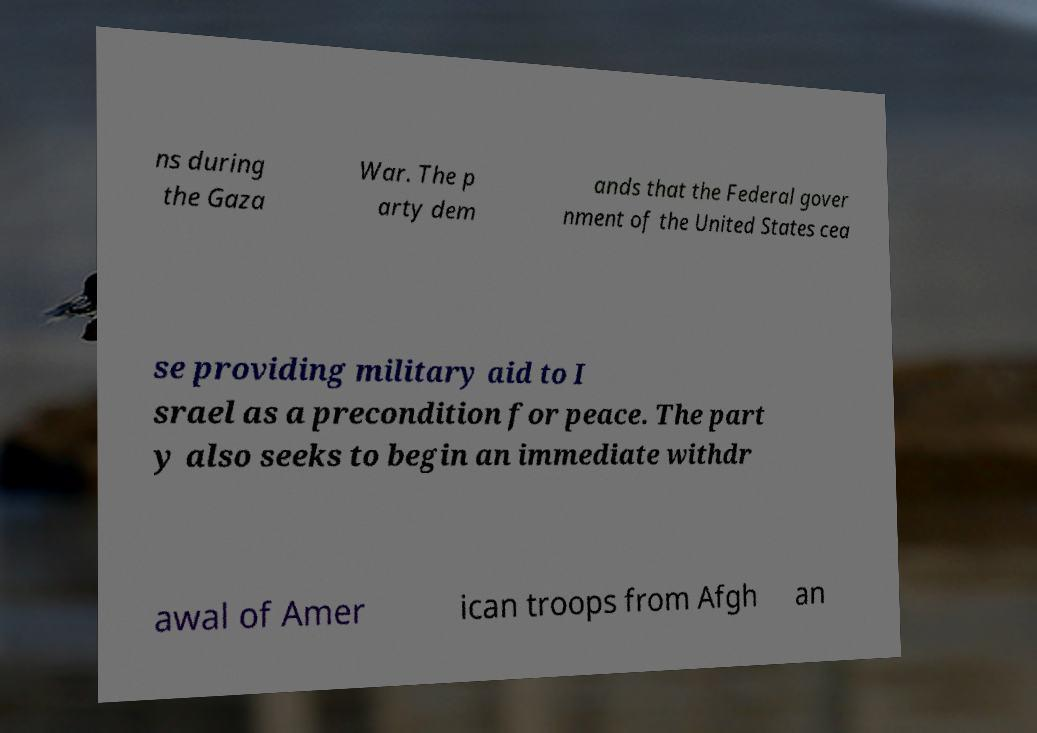Please read and relay the text visible in this image. What does it say? ns during the Gaza War. The p arty dem ands that the Federal gover nment of the United States cea se providing military aid to I srael as a precondition for peace. The part y also seeks to begin an immediate withdr awal of Amer ican troops from Afgh an 